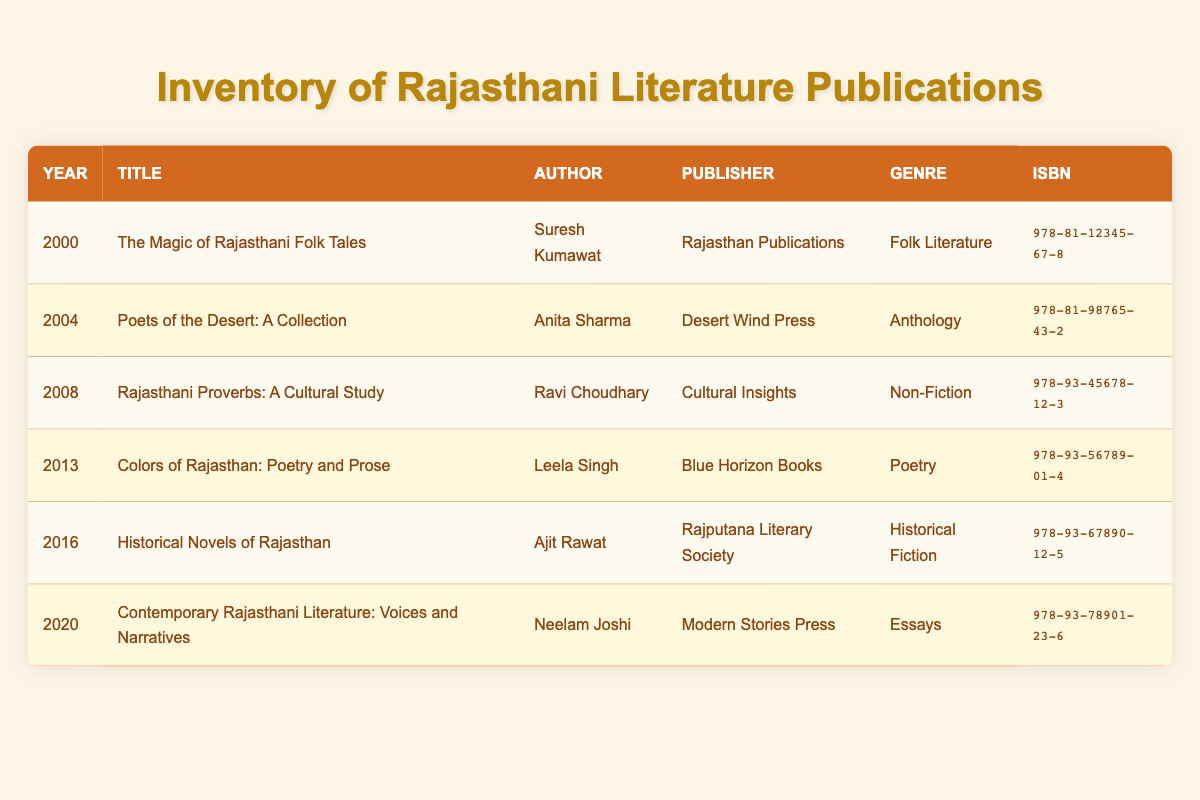What is the title of the book published in 2004? The title of the book published in 2004 can be found by looking at the row corresponding to that year in the table. The row indicates that the title is "Poets of the Desert: A Collection."
Answer: Poets of the Desert: A Collection Who is the author of "Historical Novels of Rajasthan"? To find the author of "Historical Novels of Rajasthan," I can look at the title in the table, which is listed along with its corresponding author in the same row. The author is Ajit Rawat.
Answer: Ajit Rawat How many publications were released between 2000 and 2010? By examining the table, I can count the number of rows representing publications between the years 2000 (inclusive) and 2010 (exclusive). These years are 2000, 2004, and 2008. This gives a total of 3 publications.
Answer: 3 Was there a publication in 2016 by Rajasthan Publications? To answer this, I can check the publisher of the book published in 2016. Looking at that row, the publisher is Rajputana Literary Society, not Rajasthan Publications. Thus, the answer is false.
Answer: No What is the genre of "Contemporary Rajasthani Literature: Voices and Narratives"? To find this information, I can look at the table to see which row corresponds to the title "Contemporary Rajasthani Literature: Voices and Narratives." The genre listed for this title is Essays.
Answer: Essays What is the average publication year for all the books listed? To calculate the average, I need to sum all the publication years: 2000 + 2004 + 2008 + 2013 + 2016 + 2020 = 12041. Then I divide by the number of entries, which is 6, giving an average of 12041 / 6 = 2006.83, which I round to 2007 for simplicity.
Answer: 2007 